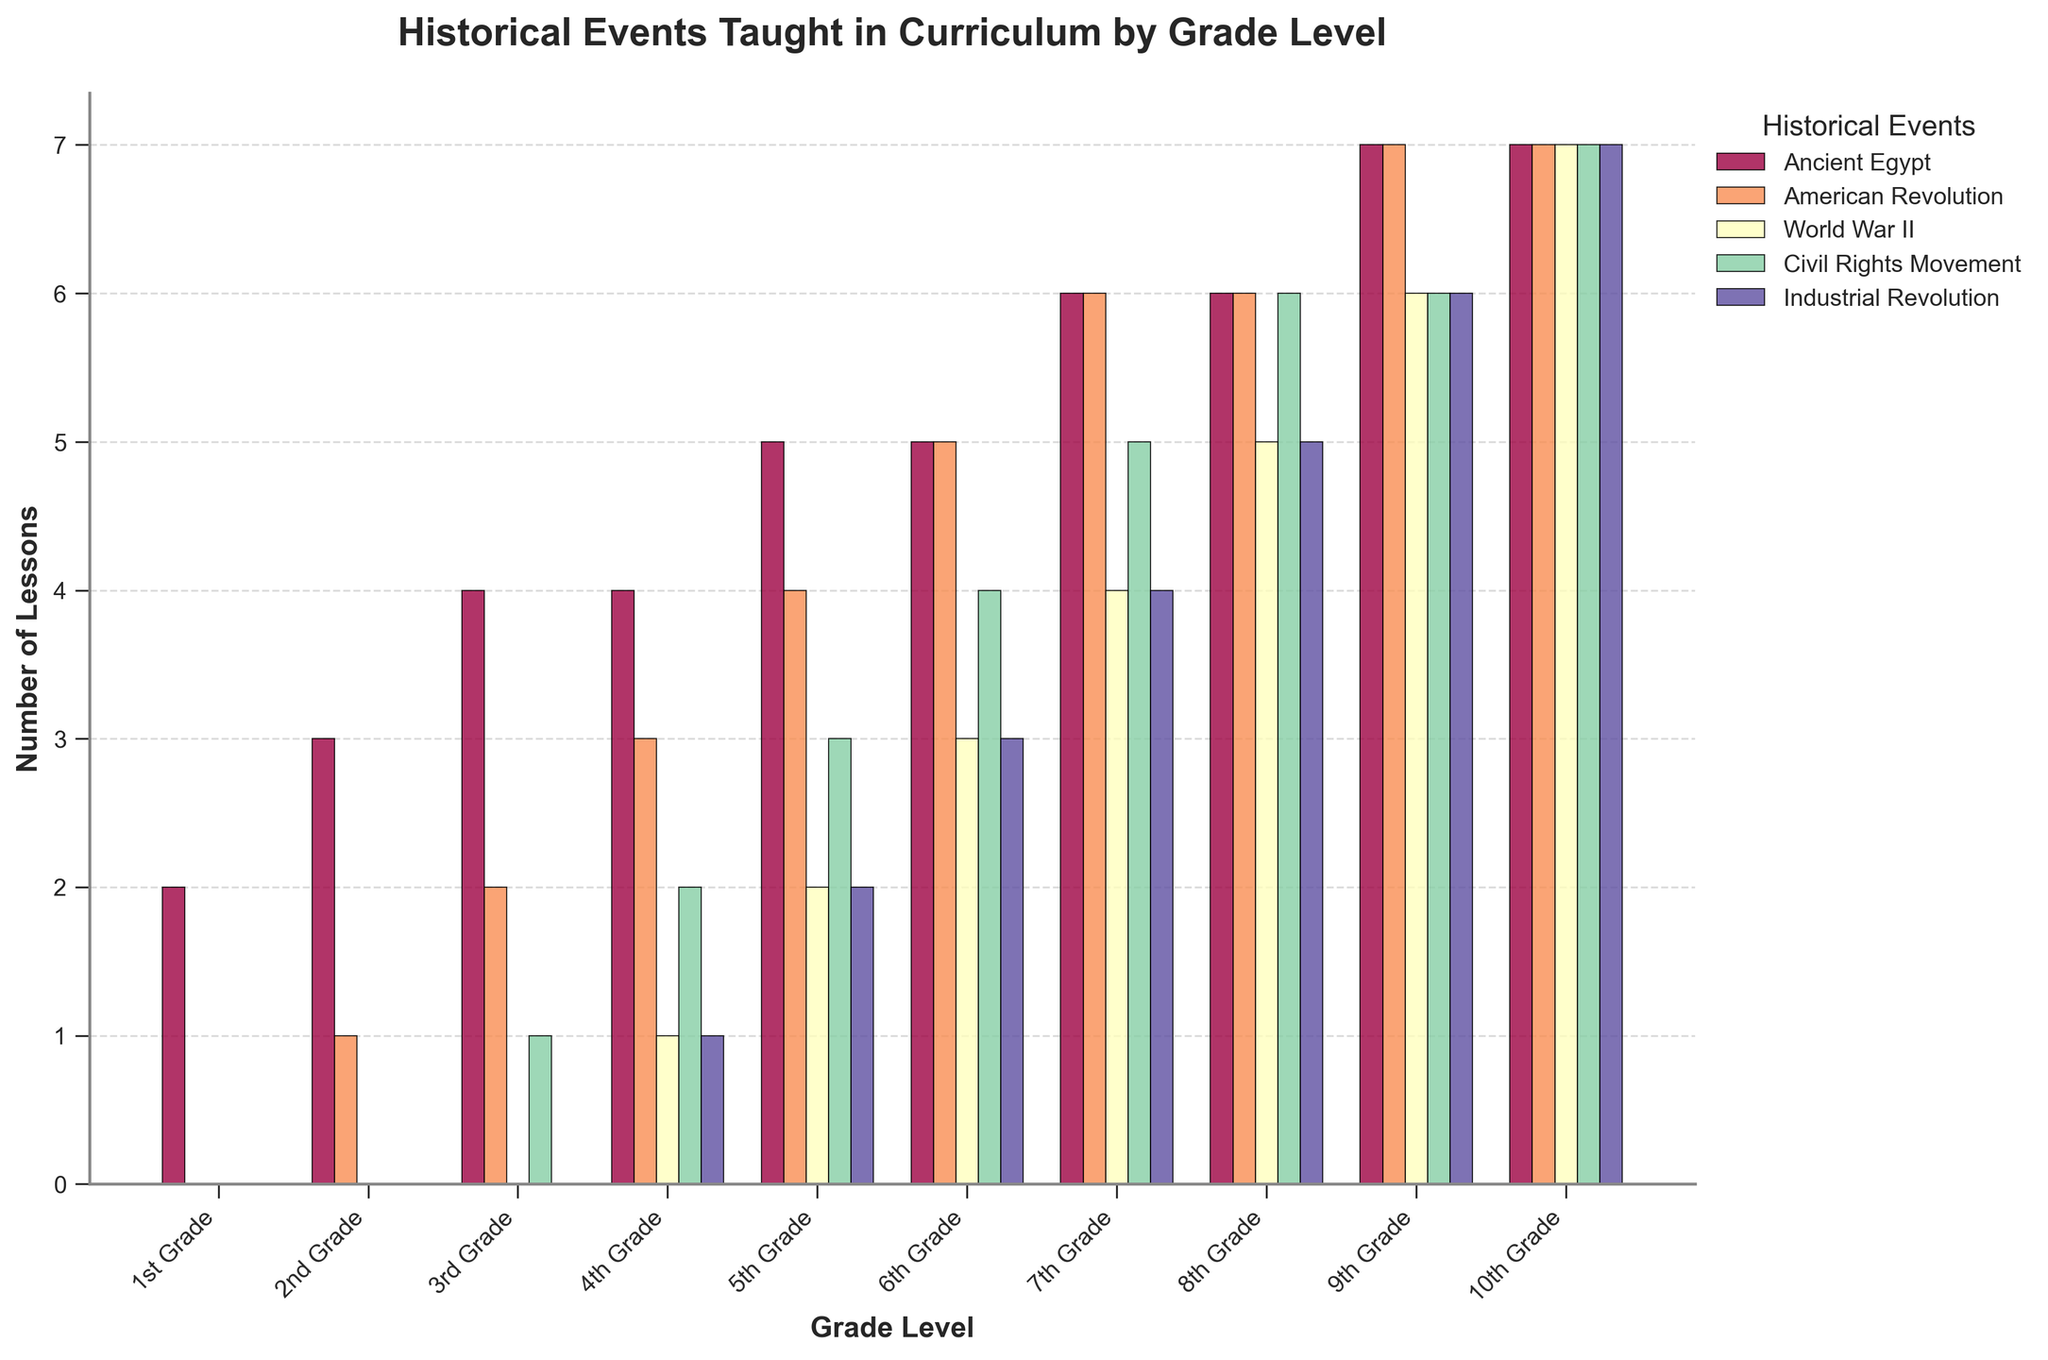What grade teaches the most lessons about the American Revolution? To find the grade with the most lessons, look for the tallest bar in the chart for the American Revolution. This occurs for both 7th and 8th grades.
Answer: 7th and 8th Grade Which historical event has the most consistent number of lessons across all grades? Look for the event where the bars are nearly the same height across all grades. This applies to the Industrial Revolution, which consistently increases by one lesson each grade from 4th to 10th grade.
Answer: Industrial Revolution Which grade level has the highest total number of lessons for all historical events combined? Sum the number of lessons over all events for each grade and compare. The 10th grade stands out with the sum of 7 lessons each for 5 events: 7 * 5 = 35 lessons.
Answer: 10th Grade In what grade do lessons about the Civil Rights Movement first appear? Identify the first grade where a non-zero lesson count appears for the Civil Rights Movement bar. This appears first in the 3rd grade.
Answer: 3rd Grade How does the number of World War II lessons in 9th grade compare to the number of Civil Rights Movement lessons in 7th grade? Check the height of the bars for World War II in 9th grade and Civil Rights Movement in 7th grade. Both have 6 lessons.
Answer: Equal How many more lessons does 7th grade have on Ancient Egypt compared to 1st grade? Subtract the number of Ancient Egypt lessons in 1st grade from those in 7th grade. 7th grade has 6 lessons and 1st grade has 2: 6 - 2 = 4 lessons.
Answer: 4 lessons Which historical event has the highest increase in the number of lessons between 5th grade and 6th grade? Calculate the difference in lessons between grades 5 and 6 for each event. The Civil Rights Movement increases from 3 to 4 lessons, which is the highest increase of 1 lesson.
Answer: Civil Rights Movement Which grade level includes the introduction of World War II lessons? Look for the first non-zero value for World War II lessons. It appears first in the 4th grade with 1 lesson.
Answer: 4th Grade 